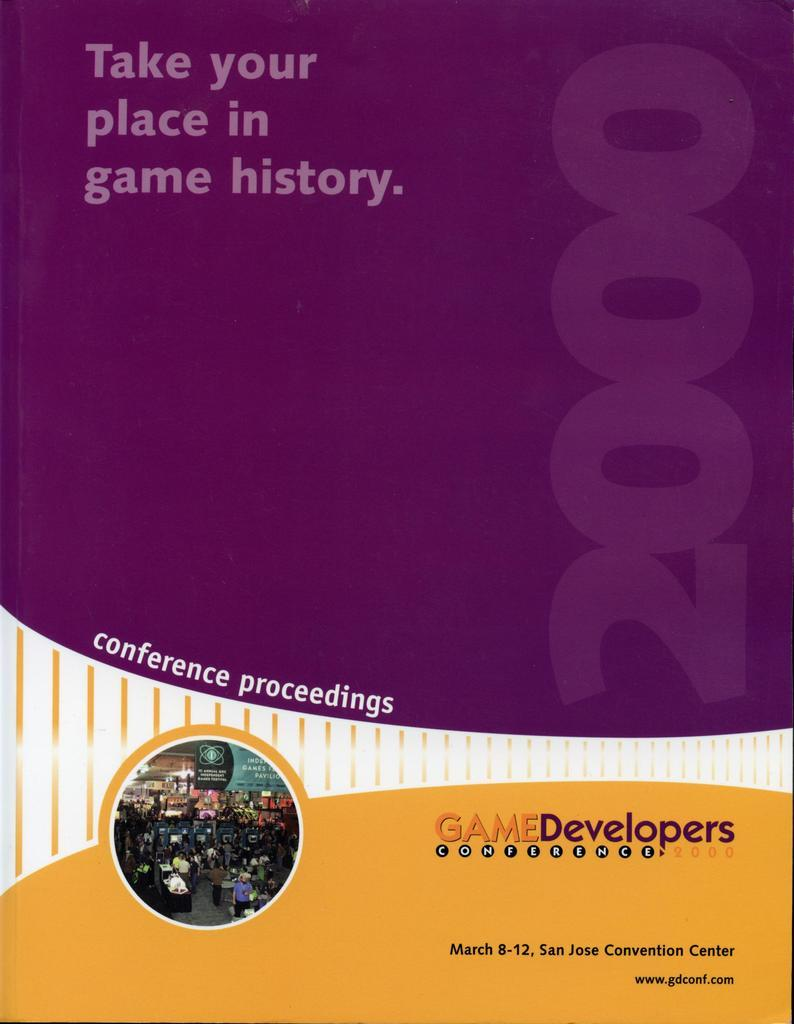Provide a one-sentence caption for the provided image. poster for game developers conference on march 8-12, 2000. 